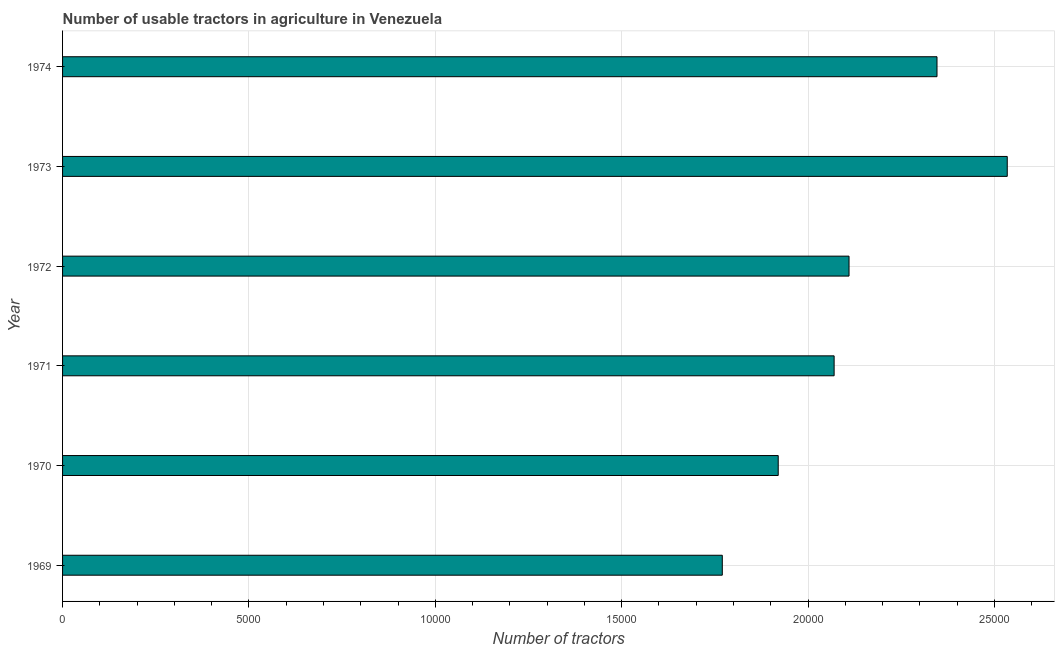What is the title of the graph?
Your answer should be compact. Number of usable tractors in agriculture in Venezuela. What is the label or title of the X-axis?
Offer a terse response. Number of tractors. What is the number of tractors in 1973?
Offer a very short reply. 2.53e+04. Across all years, what is the maximum number of tractors?
Make the answer very short. 2.53e+04. Across all years, what is the minimum number of tractors?
Keep it short and to the point. 1.77e+04. In which year was the number of tractors minimum?
Give a very brief answer. 1969. What is the sum of the number of tractors?
Your response must be concise. 1.28e+05. What is the difference between the number of tractors in 1972 and 1973?
Your answer should be compact. -4245. What is the average number of tractors per year?
Offer a very short reply. 2.12e+04. What is the median number of tractors?
Keep it short and to the point. 2.09e+04. What is the ratio of the number of tractors in 1970 to that in 1971?
Keep it short and to the point. 0.93. Is the number of tractors in 1970 less than that in 1974?
Give a very brief answer. Yes. What is the difference between the highest and the second highest number of tractors?
Offer a terse response. 1885. Is the sum of the number of tractors in 1969 and 1972 greater than the maximum number of tractors across all years?
Your response must be concise. Yes. What is the difference between the highest and the lowest number of tractors?
Ensure brevity in your answer.  7645. How many years are there in the graph?
Provide a succinct answer. 6. What is the Number of tractors in 1969?
Provide a short and direct response. 1.77e+04. What is the Number of tractors of 1970?
Offer a very short reply. 1.92e+04. What is the Number of tractors in 1971?
Offer a very short reply. 2.07e+04. What is the Number of tractors in 1972?
Your answer should be very brief. 2.11e+04. What is the Number of tractors in 1973?
Ensure brevity in your answer.  2.53e+04. What is the Number of tractors in 1974?
Keep it short and to the point. 2.35e+04. What is the difference between the Number of tractors in 1969 and 1970?
Ensure brevity in your answer.  -1500. What is the difference between the Number of tractors in 1969 and 1971?
Provide a succinct answer. -3000. What is the difference between the Number of tractors in 1969 and 1972?
Keep it short and to the point. -3400. What is the difference between the Number of tractors in 1969 and 1973?
Your answer should be compact. -7645. What is the difference between the Number of tractors in 1969 and 1974?
Provide a succinct answer. -5760. What is the difference between the Number of tractors in 1970 and 1971?
Your answer should be compact. -1500. What is the difference between the Number of tractors in 1970 and 1972?
Provide a short and direct response. -1900. What is the difference between the Number of tractors in 1970 and 1973?
Ensure brevity in your answer.  -6145. What is the difference between the Number of tractors in 1970 and 1974?
Provide a succinct answer. -4260. What is the difference between the Number of tractors in 1971 and 1972?
Your answer should be compact. -400. What is the difference between the Number of tractors in 1971 and 1973?
Your answer should be very brief. -4645. What is the difference between the Number of tractors in 1971 and 1974?
Keep it short and to the point. -2760. What is the difference between the Number of tractors in 1972 and 1973?
Your answer should be compact. -4245. What is the difference between the Number of tractors in 1972 and 1974?
Make the answer very short. -2360. What is the difference between the Number of tractors in 1973 and 1974?
Ensure brevity in your answer.  1885. What is the ratio of the Number of tractors in 1969 to that in 1970?
Make the answer very short. 0.92. What is the ratio of the Number of tractors in 1969 to that in 1971?
Your answer should be compact. 0.85. What is the ratio of the Number of tractors in 1969 to that in 1972?
Your answer should be compact. 0.84. What is the ratio of the Number of tractors in 1969 to that in 1973?
Make the answer very short. 0.7. What is the ratio of the Number of tractors in 1969 to that in 1974?
Offer a terse response. 0.75. What is the ratio of the Number of tractors in 1970 to that in 1971?
Your answer should be compact. 0.93. What is the ratio of the Number of tractors in 1970 to that in 1972?
Offer a very short reply. 0.91. What is the ratio of the Number of tractors in 1970 to that in 1973?
Give a very brief answer. 0.76. What is the ratio of the Number of tractors in 1970 to that in 1974?
Provide a short and direct response. 0.82. What is the ratio of the Number of tractors in 1971 to that in 1973?
Provide a succinct answer. 0.82. What is the ratio of the Number of tractors in 1971 to that in 1974?
Provide a succinct answer. 0.88. What is the ratio of the Number of tractors in 1972 to that in 1973?
Offer a very short reply. 0.83. What is the ratio of the Number of tractors in 1972 to that in 1974?
Offer a very short reply. 0.9. What is the ratio of the Number of tractors in 1973 to that in 1974?
Your answer should be compact. 1.08. 